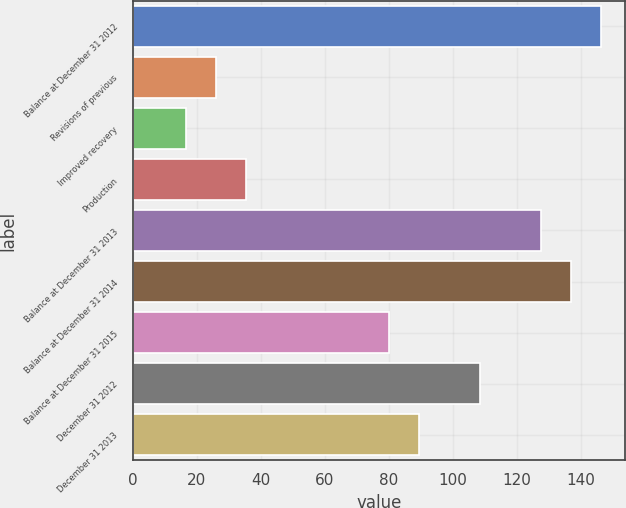Convert chart. <chart><loc_0><loc_0><loc_500><loc_500><bar_chart><fcel>Balance at December 31 2012<fcel>Revisions of previous<fcel>Improved recovery<fcel>Production<fcel>Balance at December 31 2013<fcel>Balance at December 31 2014<fcel>Balance at December 31 2015<fcel>December 31 2012<fcel>December 31 2013<nl><fcel>146.5<fcel>26<fcel>16.5<fcel>35.5<fcel>127.5<fcel>137<fcel>80<fcel>108.5<fcel>89.5<nl></chart> 